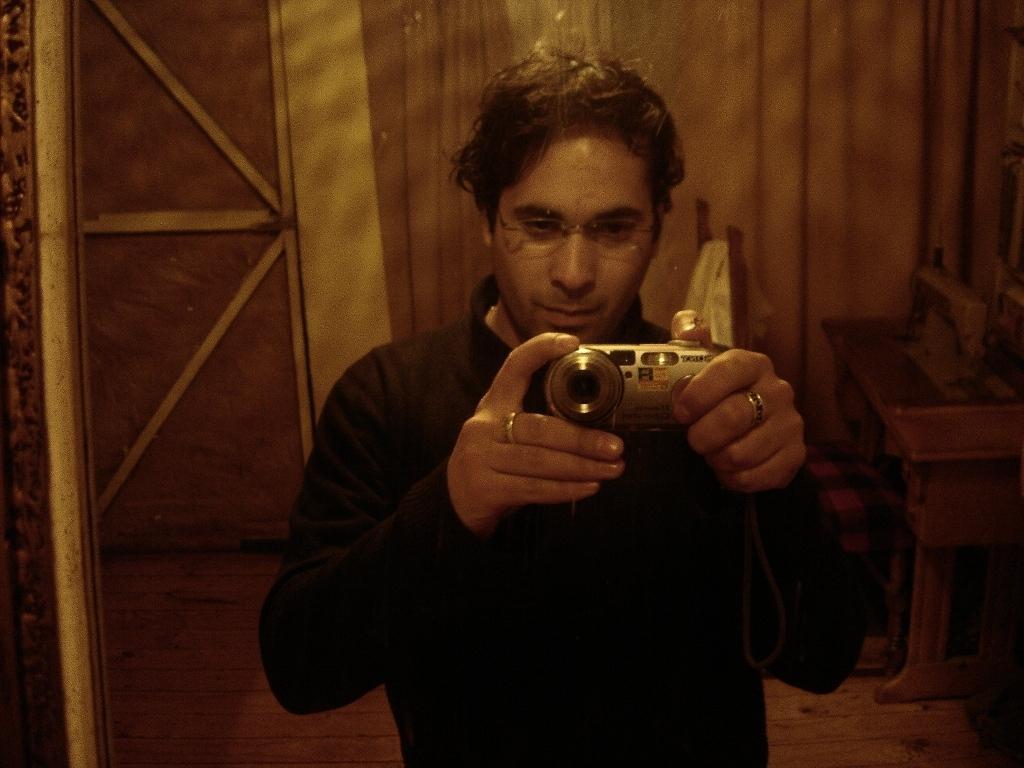How would you summarize this image in a sentence or two? This is the picture of a man in black shirt holding a camera. The man having a ring to his both hands and background of this man is a wooden wall. 